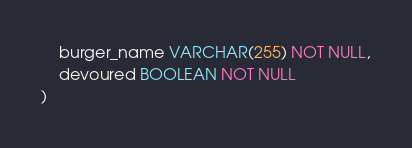<code> <loc_0><loc_0><loc_500><loc_500><_SQL_>    burger_name VARCHAR(255) NOT NULL,
    devoured BOOLEAN NOT NULL
)</code> 